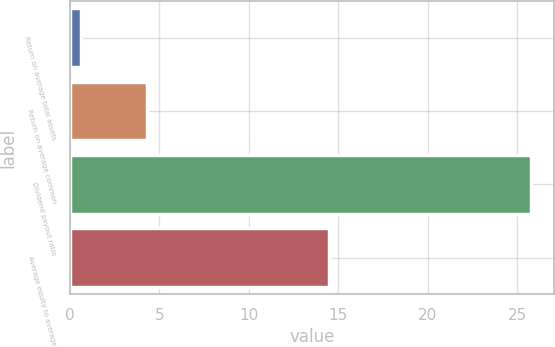<chart> <loc_0><loc_0><loc_500><loc_500><bar_chart><fcel>Return on average total assets<fcel>Return on average common<fcel>Dividend payout ratio<fcel>Average equity to average<nl><fcel>0.62<fcel>4.3<fcel>25.73<fcel>14.46<nl></chart> 